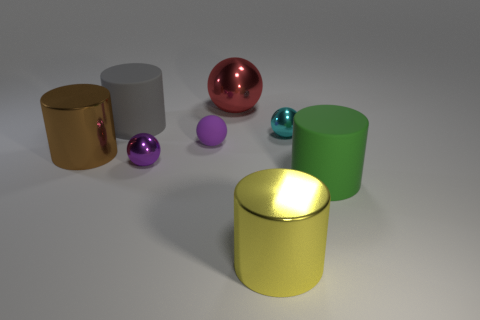Subtract all large gray cylinders. How many cylinders are left? 3 Add 1 tiny purple balls. How many objects exist? 9 Subtract all red balls. How many balls are left? 3 Subtract 3 balls. How many balls are left? 1 Subtract all green balls. Subtract all cyan blocks. How many balls are left? 4 Subtract all cyan balls. How many blue cylinders are left? 0 Add 1 small rubber objects. How many small rubber objects exist? 2 Subtract 0 brown cubes. How many objects are left? 8 Subtract all tiny purple spheres. Subtract all purple matte spheres. How many objects are left? 5 Add 2 big gray rubber cylinders. How many big gray rubber cylinders are left? 3 